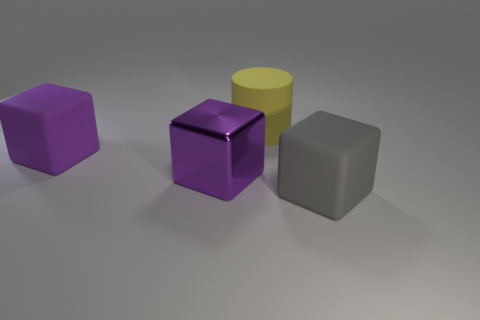Could you describe the lighting and shadows in the scene? The scene appears to be illuminated by a diffuse light source coming from above, slightly favoring the left side, given the soft, gentle shadows cast towards the right. The shadows are not overly harsh, which suggests that the environment is lit by an ambient light possibly mimicking an overcast sky or softbox lighting typically used in photography studios. 